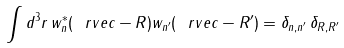Convert formula to latex. <formula><loc_0><loc_0><loc_500><loc_500>\int d ^ { 3 } r \, w _ { n } ^ { * } ( \ r v e c - R ) w _ { n ^ { \prime } } ( \ r v e c - R ^ { \prime } ) = \delta _ { n , n ^ { \prime } } \, \delta _ { R , R ^ { \prime } }</formula> 